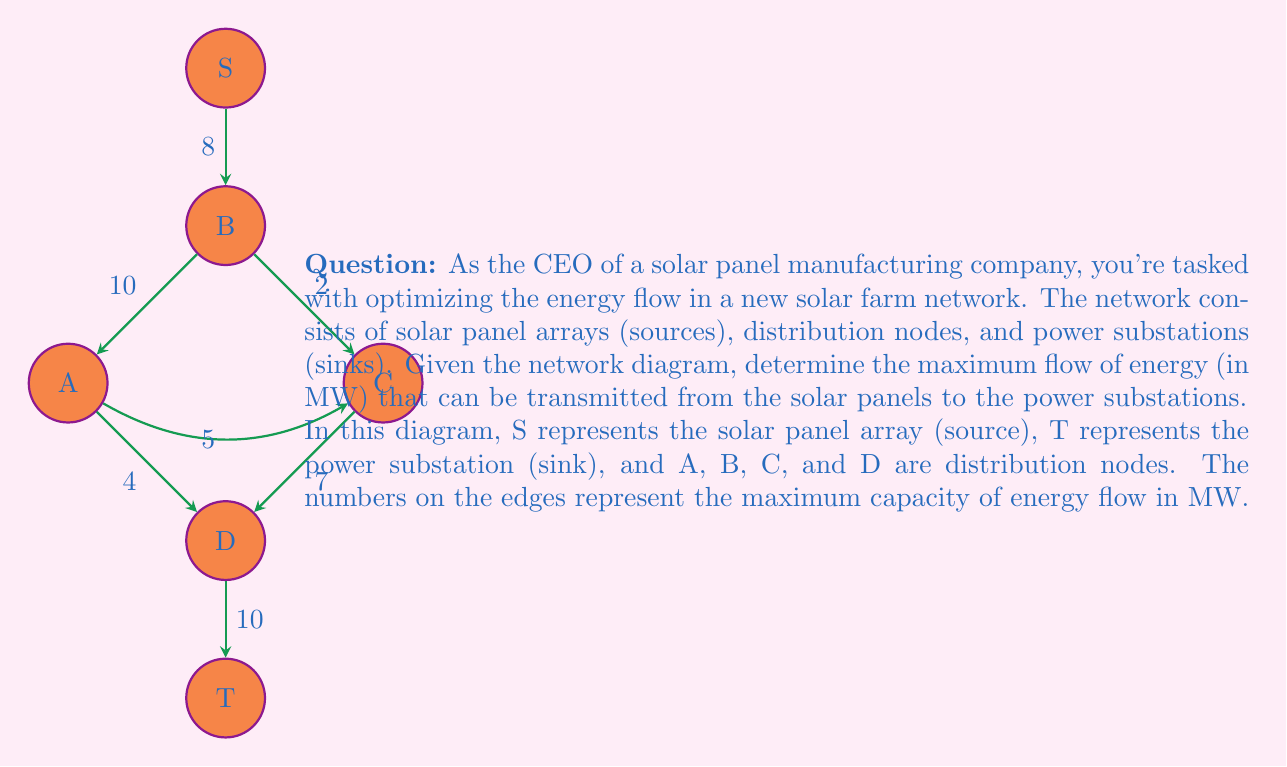Give your solution to this math problem. To solve this problem, we'll use the Ford-Fulkerson algorithm to find the maximum flow in the network. Here's a step-by-step explanation:

1) Initialize the flow to 0 for all edges.

2) Find an augmenting path from S to T. We can use DFS or BFS for this. Let's go through the paths:

   Path 1: S -> B -> A -> D -> T
   Bottleneck: min(8, 10, 4, 10) = 4 MW
   Update flow: 4 MW

3) Find another augmenting path:

   Path 2: S -> B -> C -> D -> T
   Bottleneck: min(8-4, 2, 7, 10-4) = 2 MW
   Update flow: 4 + 2 = 6 MW

4) Find another augmenting path:

   Path 3: S -> B -> C -> A -> D -> T
   Bottleneck: min(8-6, 2-2, 5, 4-4, 10-6) = 0 MW

5) No more augmenting paths are available. The maximum flow has been reached.

The maximum flow is the sum of the flows in all augmenting paths: 4 + 2 = 6 MW.

We can verify this result by looking at the cut in the graph. The minimum cut is:
$$(S, \{A, B, C, D, T\})$$
with a capacity of 8 MW, which matches our maximum flow of 6 MW plus the unused 2 MW capacity on the S-B edge.

Therefore, the maximum flow of energy that can be transmitted from the solar panels to the power substations is 6 MW.
Answer: 6 MW 